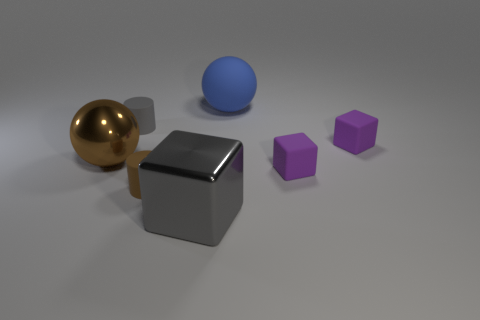There is a large thing that is in front of the small brown rubber cylinder; what is its color?
Provide a short and direct response. Gray. There is a small cylinder that is right of the matte thing that is left of the brown matte cylinder; what is it made of?
Ensure brevity in your answer.  Rubber. Is there a blue matte sphere that has the same size as the brown metallic object?
Make the answer very short. Yes. What number of objects are big things in front of the blue sphere or purple rubber cubes behind the big brown thing?
Make the answer very short. 3. There is a block on the left side of the big blue rubber sphere; is its size the same as the gray thing that is behind the gray metal cube?
Make the answer very short. No. Is there a large block that is in front of the metallic thing left of the brown rubber object?
Ensure brevity in your answer.  Yes. There is a small gray object; how many tiny purple objects are on the right side of it?
Offer a very short reply. 2. What number of other objects are the same color as the big matte sphere?
Provide a short and direct response. 0. Are there fewer brown metal balls that are on the right side of the big gray metal thing than small purple rubber blocks to the left of the large rubber object?
Keep it short and to the point. No. What number of things are small purple matte objects that are behind the big brown metallic object or small purple cubes?
Your answer should be compact. 2. 